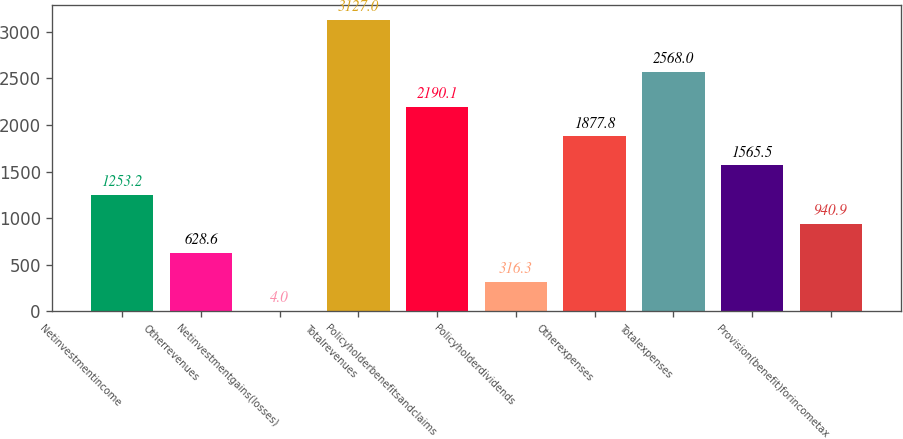Convert chart to OTSL. <chart><loc_0><loc_0><loc_500><loc_500><bar_chart><fcel>Netinvestmentincome<fcel>Otherrevenues<fcel>Netinvestmentgains(losses)<fcel>Totalrevenues<fcel>Policyholderbenefitsandclaims<fcel>Policyholderdividends<fcel>Otherexpenses<fcel>Totalexpenses<fcel>Unnamed: 8<fcel>Provision(benefit)forincometax<nl><fcel>1253.2<fcel>628.6<fcel>4<fcel>3127<fcel>2190.1<fcel>316.3<fcel>1877.8<fcel>2568<fcel>1565.5<fcel>940.9<nl></chart> 